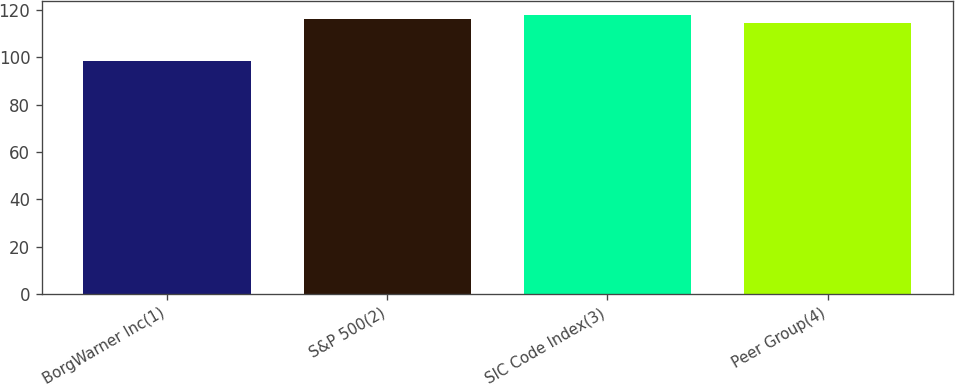Convert chart to OTSL. <chart><loc_0><loc_0><loc_500><loc_500><bar_chart><fcel>BorgWarner Inc(1)<fcel>S&P 500(2)<fcel>SIC Code Index(3)<fcel>Peer Group(4)<nl><fcel>98.41<fcel>116.14<fcel>118.01<fcel>114.27<nl></chart> 